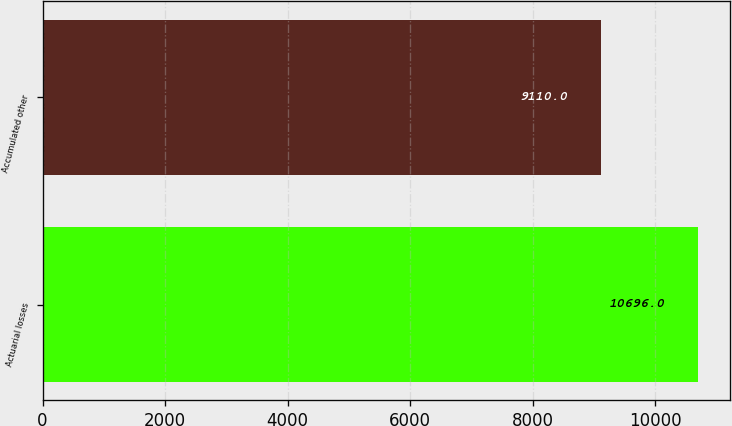<chart> <loc_0><loc_0><loc_500><loc_500><bar_chart><fcel>Actuarial losses<fcel>Accumulated other<nl><fcel>10696<fcel>9110<nl></chart> 